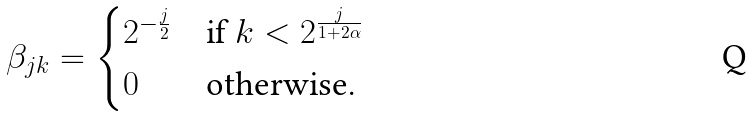<formula> <loc_0><loc_0><loc_500><loc_500>\beta _ { j k } = \begin{cases} 2 ^ { - \frac { j } { 2 } } & \text {if $k<2^{\frac{j}{1+2\alpha}}$} \\ 0 & \text {otherwise} . \end{cases}</formula> 